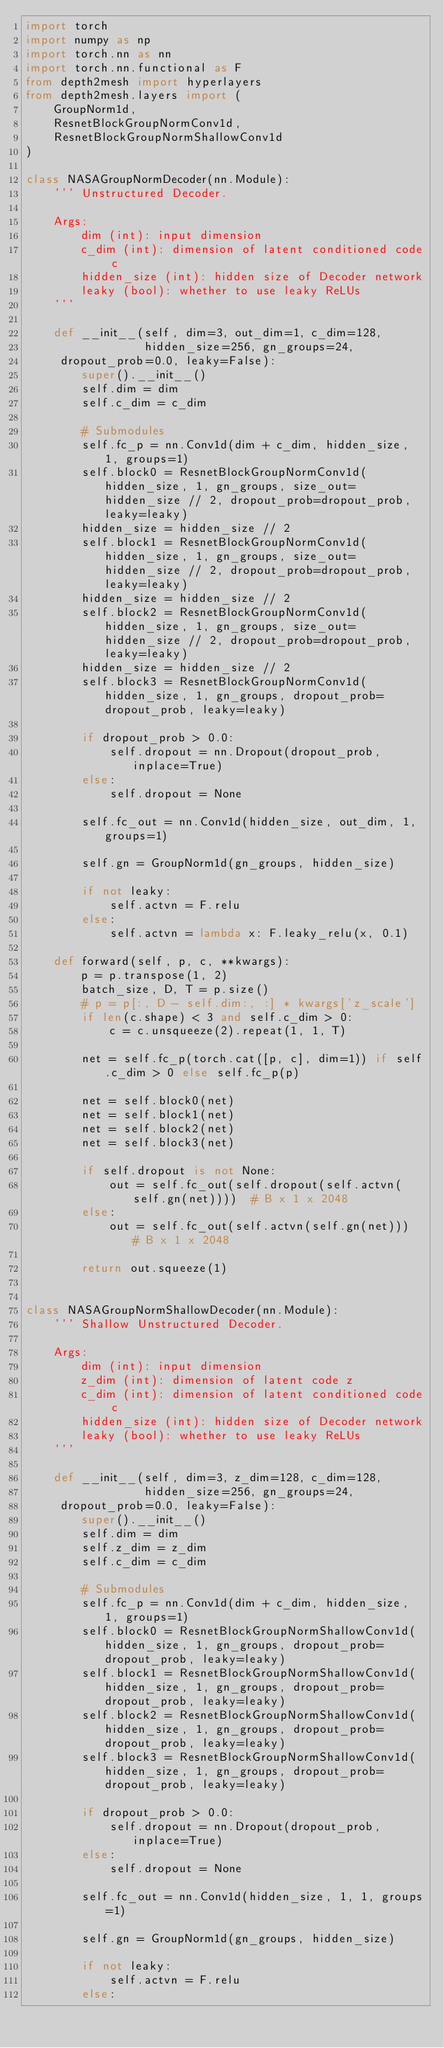Convert code to text. <code><loc_0><loc_0><loc_500><loc_500><_Python_>import torch
import numpy as np
import torch.nn as nn
import torch.nn.functional as F
from depth2mesh import hyperlayers
from depth2mesh.layers import (
    GroupNorm1d,
    ResnetBlockGroupNormConv1d,
    ResnetBlockGroupNormShallowConv1d
)

class NASAGroupNormDecoder(nn.Module):
    ''' Unstructured Decoder.

    Args:
        dim (int): input dimension
        c_dim (int): dimension of latent conditioned code c
        hidden_size (int): hidden size of Decoder network
        leaky (bool): whether to use leaky ReLUs
    '''

    def __init__(self, dim=3, out_dim=1, c_dim=128,
                 hidden_size=256, gn_groups=24,
		 dropout_prob=0.0, leaky=False):
        super().__init__()
        self.dim = dim
        self.c_dim = c_dim

        # Submodules
        self.fc_p = nn.Conv1d(dim + c_dim, hidden_size, 1, groups=1)
        self.block0 = ResnetBlockGroupNormConv1d(hidden_size, 1, gn_groups, size_out=hidden_size // 2, dropout_prob=dropout_prob, leaky=leaky)
        hidden_size = hidden_size // 2
        self.block1 = ResnetBlockGroupNormConv1d(hidden_size, 1, gn_groups, size_out=hidden_size // 2, dropout_prob=dropout_prob, leaky=leaky)
        hidden_size = hidden_size // 2
        self.block2 = ResnetBlockGroupNormConv1d(hidden_size, 1, gn_groups, size_out=hidden_size // 2, dropout_prob=dropout_prob, leaky=leaky)
        hidden_size = hidden_size // 2
        self.block3 = ResnetBlockGroupNormConv1d(hidden_size, 1, gn_groups, dropout_prob=dropout_prob, leaky=leaky)

        if dropout_prob > 0.0:
            self.dropout = nn.Dropout(dropout_prob, inplace=True)
        else:
            self.dropout = None

        self.fc_out = nn.Conv1d(hidden_size, out_dim, 1, groups=1)

        self.gn = GroupNorm1d(gn_groups, hidden_size)

        if not leaky:
            self.actvn = F.relu
        else:
            self.actvn = lambda x: F.leaky_relu(x, 0.1)

    def forward(self, p, c, **kwargs):
        p = p.transpose(1, 2)
        batch_size, D, T = p.size()
        # p = p[:, D - self.dim:, :] * kwargs['z_scale']
        if len(c.shape) < 3 and self.c_dim > 0:
            c = c.unsqueeze(2).repeat(1, 1, T)

        net = self.fc_p(torch.cat([p, c], dim=1)) if self.c_dim > 0 else self.fc_p(p)

        net = self.block0(net)
        net = self.block1(net)
        net = self.block2(net)
        net = self.block3(net)

        if self.dropout is not None:
            out = self.fc_out(self.dropout(self.actvn(self.gn(net))))  # B x 1 x 2048
        else:
            out = self.fc_out(self.actvn(self.gn(net)))  # B x 1 x 2048

        return out.squeeze(1)


class NASAGroupNormShallowDecoder(nn.Module):
    ''' Shallow Unstructured Decoder.

    Args:
        dim (int): input dimension
        z_dim (int): dimension of latent code z
        c_dim (int): dimension of latent conditioned code c
        hidden_size (int): hidden size of Decoder network
        leaky (bool): whether to use leaky ReLUs
    '''

    def __init__(self, dim=3, z_dim=128, c_dim=128,
                 hidden_size=256, gn_groups=24,
		 dropout_prob=0.0, leaky=False):
        super().__init__()
        self.dim = dim
        self.z_dim = z_dim
        self.c_dim = c_dim

        # Submodules
        self.fc_p = nn.Conv1d(dim + c_dim, hidden_size, 1, groups=1)
        self.block0 = ResnetBlockGroupNormShallowConv1d(hidden_size, 1, gn_groups, dropout_prob=dropout_prob, leaky=leaky)
        self.block1 = ResnetBlockGroupNormShallowConv1d(hidden_size, 1, gn_groups, dropout_prob=dropout_prob, leaky=leaky)
        self.block2 = ResnetBlockGroupNormShallowConv1d(hidden_size, 1, gn_groups, dropout_prob=dropout_prob, leaky=leaky)
        self.block3 = ResnetBlockGroupNormShallowConv1d(hidden_size, 1, gn_groups, dropout_prob=dropout_prob, leaky=leaky)

        if dropout_prob > 0.0:
            self.dropout = nn.Dropout(dropout_prob, inplace=True)
        else:
            self.dropout = None

        self.fc_out = nn.Conv1d(hidden_size, 1, 1, groups=1)

        self.gn = GroupNorm1d(gn_groups, hidden_size)

        if not leaky:
            self.actvn = F.relu
        else:</code> 